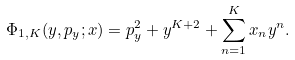Convert formula to latex. <formula><loc_0><loc_0><loc_500><loc_500>\Phi _ { 1 , K } ( y , p _ { y } ; { x } ) = p ^ { 2 } _ { y } + y ^ { K + 2 } + \sum _ { n = 1 } ^ { K } x _ { n } y ^ { n } .</formula> 